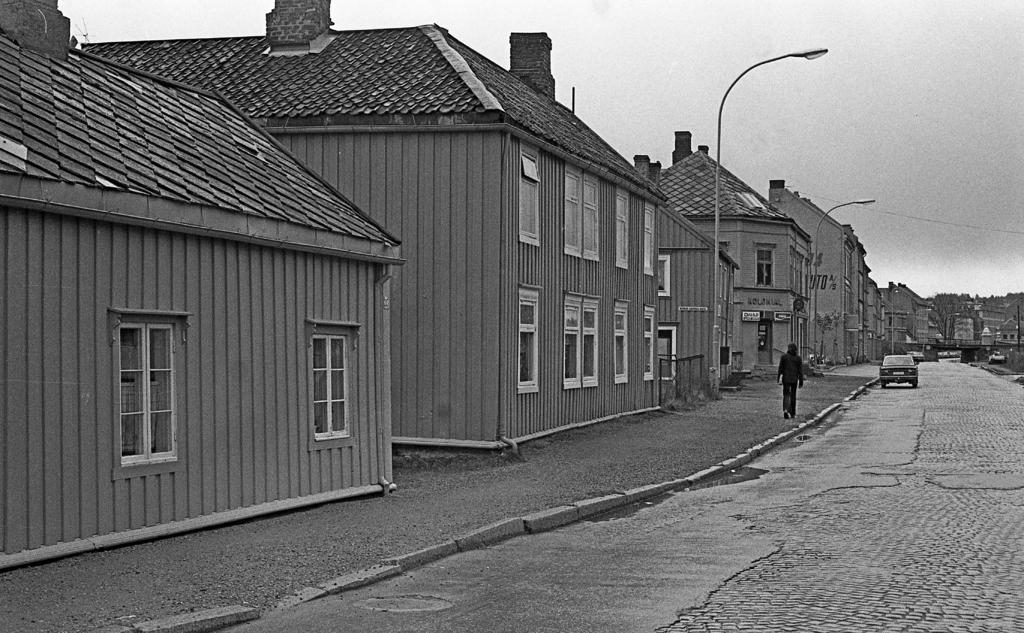What type of structures are visible in the image? There are houses with roofs and windows in the image. What mode of transportation can be seen on the road? There is a car on the road in the image. What is the person in the image doing? There is a person walking on the footpath in the image. What are the street poles supporting in the image? There are wires on the street poles in the image. What is attached to the street poles? There are boards on the street poles in the image. Can you see any goldfish swimming in the image? There are no goldfish present in the image. What type of tool is the person using to dig in the image? There is no tool or digging activity depicted in the image. 